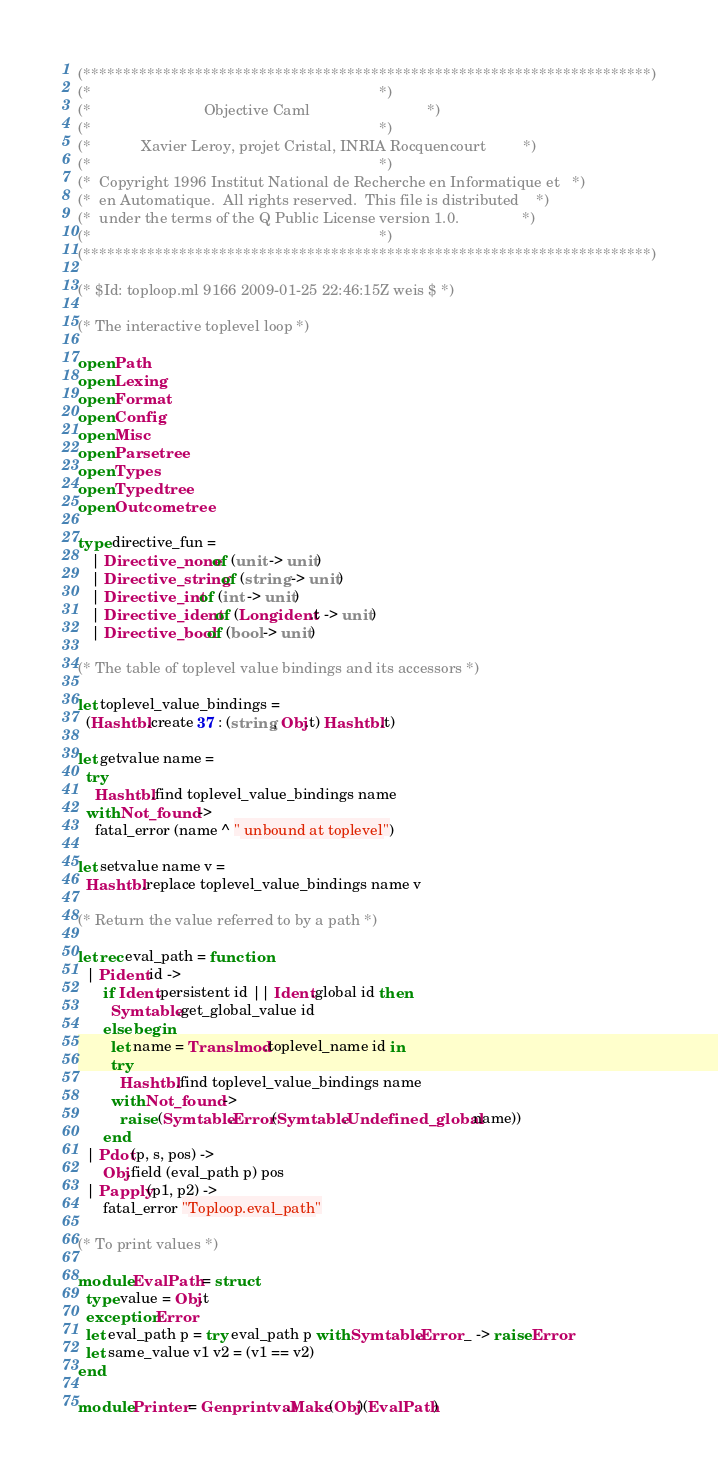Convert code to text. <code><loc_0><loc_0><loc_500><loc_500><_OCaml_>(***********************************************************************)
(*                                                                     *)
(*                           Objective Caml                            *)
(*                                                                     *)
(*            Xavier Leroy, projet Cristal, INRIA Rocquencourt         *)
(*                                                                     *)
(*  Copyright 1996 Institut National de Recherche en Informatique et   *)
(*  en Automatique.  All rights reserved.  This file is distributed    *)
(*  under the terms of the Q Public License version 1.0.               *)
(*                                                                     *)
(***********************************************************************)

(* $Id: toploop.ml 9166 2009-01-25 22:46:15Z weis $ *)

(* The interactive toplevel loop *)

open Path
open Lexing
open Format
open Config
open Misc
open Parsetree
open Types
open Typedtree
open Outcometree

type directive_fun =
   | Directive_none of (unit -> unit)
   | Directive_string of (string -> unit)
   | Directive_int of (int -> unit)
   | Directive_ident of (Longident.t -> unit)
   | Directive_bool of (bool -> unit)

(* The table of toplevel value bindings and its accessors *)

let toplevel_value_bindings =
  (Hashtbl.create 37 : (string, Obj.t) Hashtbl.t)

let getvalue name =
  try
    Hashtbl.find toplevel_value_bindings name
  with Not_found ->
    fatal_error (name ^ " unbound at toplevel")

let setvalue name v =
  Hashtbl.replace toplevel_value_bindings name v

(* Return the value referred to by a path *)

let rec eval_path = function
  | Pident id ->
      if Ident.persistent id || Ident.global id then
        Symtable.get_global_value id
      else begin
        let name = Translmod.toplevel_name id in
        try
          Hashtbl.find toplevel_value_bindings name
        with Not_found ->
          raise (Symtable.Error(Symtable.Undefined_global name))
      end
  | Pdot(p, s, pos) ->
      Obj.field (eval_path p) pos
  | Papply(p1, p2) ->
      fatal_error "Toploop.eval_path"

(* To print values *)

module EvalPath = struct
  type value = Obj.t
  exception Error
  let eval_path p = try eval_path p with Symtable.Error _ -> raise Error
  let same_value v1 v2 = (v1 == v2)
end

module Printer = Genprintval.Make(Obj)(EvalPath)
</code> 